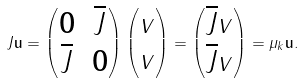Convert formula to latex. <formula><loc_0><loc_0><loc_500><loc_500>J \mathbf u = \begin{pmatrix} \mathbf 0 & \overline { J } \\ \overline { J } & \mathbf 0 \\ \end{pmatrix} \begin{pmatrix} v \\ v \end{pmatrix} = \begin{pmatrix} \overline { J } v \\ \overline { J } v \end{pmatrix} = \mu _ { k } \mathbf u .</formula> 